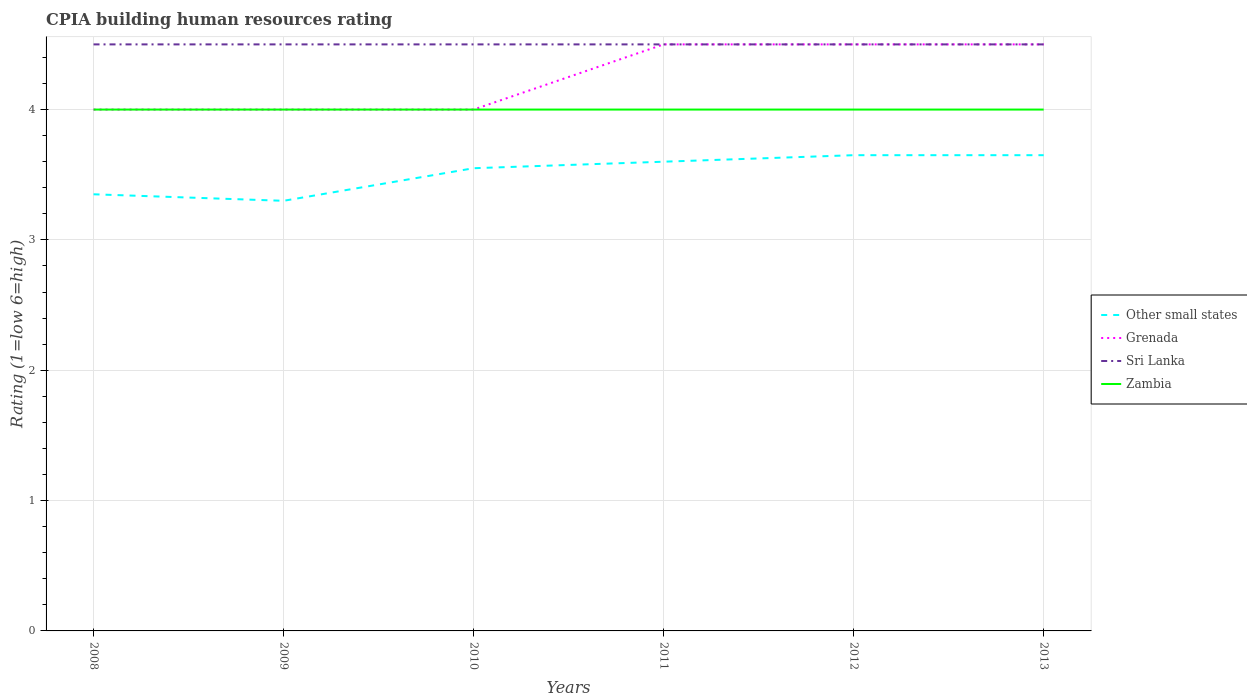Does the line corresponding to Grenada intersect with the line corresponding to Zambia?
Ensure brevity in your answer.  Yes. Across all years, what is the maximum CPIA rating in Zambia?
Give a very brief answer. 4. In which year was the CPIA rating in Sri Lanka maximum?
Your answer should be compact. 2008. What is the total CPIA rating in Zambia in the graph?
Offer a terse response. 0. What is the difference between the highest and the second highest CPIA rating in Grenada?
Keep it short and to the point. 0.5. How many lines are there?
Provide a short and direct response. 4. What is the difference between two consecutive major ticks on the Y-axis?
Provide a succinct answer. 1. Are the values on the major ticks of Y-axis written in scientific E-notation?
Make the answer very short. No. How many legend labels are there?
Provide a short and direct response. 4. What is the title of the graph?
Make the answer very short. CPIA building human resources rating. What is the label or title of the Y-axis?
Your response must be concise. Rating (1=low 6=high). What is the Rating (1=low 6=high) of Other small states in 2008?
Your answer should be compact. 3.35. What is the Rating (1=low 6=high) of Sri Lanka in 2008?
Your response must be concise. 4.5. What is the Rating (1=low 6=high) in Other small states in 2009?
Your answer should be very brief. 3.3. What is the Rating (1=low 6=high) of Sri Lanka in 2009?
Provide a succinct answer. 4.5. What is the Rating (1=low 6=high) of Zambia in 2009?
Provide a short and direct response. 4. What is the Rating (1=low 6=high) in Other small states in 2010?
Provide a succinct answer. 3.55. What is the Rating (1=low 6=high) in Zambia in 2010?
Your response must be concise. 4. What is the Rating (1=low 6=high) of Zambia in 2011?
Your response must be concise. 4. What is the Rating (1=low 6=high) of Other small states in 2012?
Ensure brevity in your answer.  3.65. What is the Rating (1=low 6=high) of Grenada in 2012?
Provide a short and direct response. 4.5. What is the Rating (1=low 6=high) in Sri Lanka in 2012?
Give a very brief answer. 4.5. What is the Rating (1=low 6=high) of Zambia in 2012?
Offer a very short reply. 4. What is the Rating (1=low 6=high) of Other small states in 2013?
Ensure brevity in your answer.  3.65. What is the Rating (1=low 6=high) in Grenada in 2013?
Your answer should be compact. 4.5. What is the Rating (1=low 6=high) in Zambia in 2013?
Give a very brief answer. 4. Across all years, what is the maximum Rating (1=low 6=high) in Other small states?
Offer a terse response. 3.65. Across all years, what is the maximum Rating (1=low 6=high) in Zambia?
Offer a very short reply. 4. Across all years, what is the minimum Rating (1=low 6=high) in Other small states?
Offer a terse response. 3.3. Across all years, what is the minimum Rating (1=low 6=high) of Grenada?
Offer a very short reply. 4. Across all years, what is the minimum Rating (1=low 6=high) in Sri Lanka?
Make the answer very short. 4.5. Across all years, what is the minimum Rating (1=low 6=high) of Zambia?
Keep it short and to the point. 4. What is the total Rating (1=low 6=high) of Other small states in the graph?
Keep it short and to the point. 21.1. What is the total Rating (1=low 6=high) in Grenada in the graph?
Provide a short and direct response. 25.5. What is the total Rating (1=low 6=high) in Sri Lanka in the graph?
Provide a succinct answer. 27. What is the total Rating (1=low 6=high) in Zambia in the graph?
Make the answer very short. 24. What is the difference between the Rating (1=low 6=high) in Other small states in 2008 and that in 2009?
Provide a short and direct response. 0.05. What is the difference between the Rating (1=low 6=high) in Grenada in 2008 and that in 2009?
Offer a very short reply. 0. What is the difference between the Rating (1=low 6=high) of Grenada in 2008 and that in 2010?
Make the answer very short. 0. What is the difference between the Rating (1=low 6=high) of Grenada in 2008 and that in 2011?
Make the answer very short. -0.5. What is the difference between the Rating (1=low 6=high) of Other small states in 2008 and that in 2012?
Your answer should be compact. -0.3. What is the difference between the Rating (1=low 6=high) in Grenada in 2008 and that in 2012?
Offer a terse response. -0.5. What is the difference between the Rating (1=low 6=high) of Sri Lanka in 2008 and that in 2012?
Provide a short and direct response. 0. What is the difference between the Rating (1=low 6=high) in Zambia in 2008 and that in 2013?
Your response must be concise. 0. What is the difference between the Rating (1=low 6=high) in Grenada in 2009 and that in 2010?
Your answer should be very brief. 0. What is the difference between the Rating (1=low 6=high) of Sri Lanka in 2009 and that in 2010?
Ensure brevity in your answer.  0. What is the difference between the Rating (1=low 6=high) in Zambia in 2009 and that in 2010?
Offer a very short reply. 0. What is the difference between the Rating (1=low 6=high) in Sri Lanka in 2009 and that in 2011?
Provide a succinct answer. 0. What is the difference between the Rating (1=low 6=high) of Zambia in 2009 and that in 2011?
Offer a terse response. 0. What is the difference between the Rating (1=low 6=high) of Other small states in 2009 and that in 2012?
Provide a succinct answer. -0.35. What is the difference between the Rating (1=low 6=high) in Sri Lanka in 2009 and that in 2012?
Give a very brief answer. 0. What is the difference between the Rating (1=low 6=high) of Other small states in 2009 and that in 2013?
Give a very brief answer. -0.35. What is the difference between the Rating (1=low 6=high) of Grenada in 2009 and that in 2013?
Your answer should be compact. -0.5. What is the difference between the Rating (1=low 6=high) of Sri Lanka in 2010 and that in 2011?
Keep it short and to the point. 0. What is the difference between the Rating (1=low 6=high) of Zambia in 2010 and that in 2011?
Give a very brief answer. 0. What is the difference between the Rating (1=low 6=high) of Other small states in 2010 and that in 2012?
Ensure brevity in your answer.  -0.1. What is the difference between the Rating (1=low 6=high) in Sri Lanka in 2010 and that in 2012?
Make the answer very short. 0. What is the difference between the Rating (1=low 6=high) in Zambia in 2010 and that in 2012?
Your answer should be very brief. 0. What is the difference between the Rating (1=low 6=high) of Zambia in 2010 and that in 2013?
Keep it short and to the point. 0. What is the difference between the Rating (1=low 6=high) in Other small states in 2011 and that in 2012?
Provide a succinct answer. -0.05. What is the difference between the Rating (1=low 6=high) in Grenada in 2011 and that in 2012?
Your response must be concise. 0. What is the difference between the Rating (1=low 6=high) of Zambia in 2011 and that in 2012?
Offer a very short reply. 0. What is the difference between the Rating (1=low 6=high) in Other small states in 2011 and that in 2013?
Your answer should be compact. -0.05. What is the difference between the Rating (1=low 6=high) in Grenada in 2011 and that in 2013?
Provide a short and direct response. 0. What is the difference between the Rating (1=low 6=high) of Sri Lanka in 2011 and that in 2013?
Ensure brevity in your answer.  0. What is the difference between the Rating (1=low 6=high) of Zambia in 2011 and that in 2013?
Make the answer very short. 0. What is the difference between the Rating (1=low 6=high) of Other small states in 2012 and that in 2013?
Offer a terse response. 0. What is the difference between the Rating (1=low 6=high) of Sri Lanka in 2012 and that in 2013?
Offer a terse response. 0. What is the difference between the Rating (1=low 6=high) of Zambia in 2012 and that in 2013?
Provide a short and direct response. 0. What is the difference between the Rating (1=low 6=high) of Other small states in 2008 and the Rating (1=low 6=high) of Grenada in 2009?
Your response must be concise. -0.65. What is the difference between the Rating (1=low 6=high) of Other small states in 2008 and the Rating (1=low 6=high) of Sri Lanka in 2009?
Keep it short and to the point. -1.15. What is the difference between the Rating (1=low 6=high) in Other small states in 2008 and the Rating (1=low 6=high) in Zambia in 2009?
Keep it short and to the point. -0.65. What is the difference between the Rating (1=low 6=high) of Sri Lanka in 2008 and the Rating (1=low 6=high) of Zambia in 2009?
Your answer should be very brief. 0.5. What is the difference between the Rating (1=low 6=high) in Other small states in 2008 and the Rating (1=low 6=high) in Grenada in 2010?
Your response must be concise. -0.65. What is the difference between the Rating (1=low 6=high) of Other small states in 2008 and the Rating (1=low 6=high) of Sri Lanka in 2010?
Offer a terse response. -1.15. What is the difference between the Rating (1=low 6=high) of Other small states in 2008 and the Rating (1=low 6=high) of Zambia in 2010?
Give a very brief answer. -0.65. What is the difference between the Rating (1=low 6=high) in Grenada in 2008 and the Rating (1=low 6=high) in Sri Lanka in 2010?
Give a very brief answer. -0.5. What is the difference between the Rating (1=low 6=high) of Grenada in 2008 and the Rating (1=low 6=high) of Zambia in 2010?
Your answer should be very brief. 0. What is the difference between the Rating (1=low 6=high) in Other small states in 2008 and the Rating (1=low 6=high) in Grenada in 2011?
Your answer should be very brief. -1.15. What is the difference between the Rating (1=low 6=high) in Other small states in 2008 and the Rating (1=low 6=high) in Sri Lanka in 2011?
Your answer should be very brief. -1.15. What is the difference between the Rating (1=low 6=high) of Other small states in 2008 and the Rating (1=low 6=high) of Zambia in 2011?
Your answer should be compact. -0.65. What is the difference between the Rating (1=low 6=high) in Other small states in 2008 and the Rating (1=low 6=high) in Grenada in 2012?
Provide a short and direct response. -1.15. What is the difference between the Rating (1=low 6=high) of Other small states in 2008 and the Rating (1=low 6=high) of Sri Lanka in 2012?
Make the answer very short. -1.15. What is the difference between the Rating (1=low 6=high) in Other small states in 2008 and the Rating (1=low 6=high) in Zambia in 2012?
Your response must be concise. -0.65. What is the difference between the Rating (1=low 6=high) in Sri Lanka in 2008 and the Rating (1=low 6=high) in Zambia in 2012?
Offer a very short reply. 0.5. What is the difference between the Rating (1=low 6=high) of Other small states in 2008 and the Rating (1=low 6=high) of Grenada in 2013?
Your answer should be very brief. -1.15. What is the difference between the Rating (1=low 6=high) in Other small states in 2008 and the Rating (1=low 6=high) in Sri Lanka in 2013?
Keep it short and to the point. -1.15. What is the difference between the Rating (1=low 6=high) in Other small states in 2008 and the Rating (1=low 6=high) in Zambia in 2013?
Provide a succinct answer. -0.65. What is the difference between the Rating (1=low 6=high) in Sri Lanka in 2008 and the Rating (1=low 6=high) in Zambia in 2013?
Keep it short and to the point. 0.5. What is the difference between the Rating (1=low 6=high) in Other small states in 2009 and the Rating (1=low 6=high) in Grenada in 2010?
Ensure brevity in your answer.  -0.7. What is the difference between the Rating (1=low 6=high) of Other small states in 2009 and the Rating (1=low 6=high) of Sri Lanka in 2010?
Your response must be concise. -1.2. What is the difference between the Rating (1=low 6=high) in Grenada in 2009 and the Rating (1=low 6=high) in Sri Lanka in 2010?
Keep it short and to the point. -0.5. What is the difference between the Rating (1=low 6=high) in Grenada in 2009 and the Rating (1=low 6=high) in Zambia in 2010?
Offer a terse response. 0. What is the difference between the Rating (1=low 6=high) in Other small states in 2009 and the Rating (1=low 6=high) in Grenada in 2011?
Provide a short and direct response. -1.2. What is the difference between the Rating (1=low 6=high) of Other small states in 2009 and the Rating (1=low 6=high) of Sri Lanka in 2011?
Keep it short and to the point. -1.2. What is the difference between the Rating (1=low 6=high) in Sri Lanka in 2009 and the Rating (1=low 6=high) in Zambia in 2011?
Ensure brevity in your answer.  0.5. What is the difference between the Rating (1=low 6=high) of Other small states in 2009 and the Rating (1=low 6=high) of Grenada in 2013?
Your response must be concise. -1.2. What is the difference between the Rating (1=low 6=high) in Other small states in 2009 and the Rating (1=low 6=high) in Sri Lanka in 2013?
Provide a succinct answer. -1.2. What is the difference between the Rating (1=low 6=high) in Other small states in 2009 and the Rating (1=low 6=high) in Zambia in 2013?
Give a very brief answer. -0.7. What is the difference between the Rating (1=low 6=high) in Sri Lanka in 2009 and the Rating (1=low 6=high) in Zambia in 2013?
Ensure brevity in your answer.  0.5. What is the difference between the Rating (1=low 6=high) in Other small states in 2010 and the Rating (1=low 6=high) in Grenada in 2011?
Your answer should be compact. -0.95. What is the difference between the Rating (1=low 6=high) in Other small states in 2010 and the Rating (1=low 6=high) in Sri Lanka in 2011?
Provide a short and direct response. -0.95. What is the difference between the Rating (1=low 6=high) of Other small states in 2010 and the Rating (1=low 6=high) of Zambia in 2011?
Keep it short and to the point. -0.45. What is the difference between the Rating (1=low 6=high) of Grenada in 2010 and the Rating (1=low 6=high) of Sri Lanka in 2011?
Your answer should be very brief. -0.5. What is the difference between the Rating (1=low 6=high) of Grenada in 2010 and the Rating (1=low 6=high) of Zambia in 2011?
Keep it short and to the point. 0. What is the difference between the Rating (1=low 6=high) of Sri Lanka in 2010 and the Rating (1=low 6=high) of Zambia in 2011?
Make the answer very short. 0.5. What is the difference between the Rating (1=low 6=high) of Other small states in 2010 and the Rating (1=low 6=high) of Grenada in 2012?
Make the answer very short. -0.95. What is the difference between the Rating (1=low 6=high) in Other small states in 2010 and the Rating (1=low 6=high) in Sri Lanka in 2012?
Provide a short and direct response. -0.95. What is the difference between the Rating (1=low 6=high) in Other small states in 2010 and the Rating (1=low 6=high) in Zambia in 2012?
Your answer should be very brief. -0.45. What is the difference between the Rating (1=low 6=high) of Grenada in 2010 and the Rating (1=low 6=high) of Zambia in 2012?
Offer a terse response. 0. What is the difference between the Rating (1=low 6=high) of Sri Lanka in 2010 and the Rating (1=low 6=high) of Zambia in 2012?
Provide a succinct answer. 0.5. What is the difference between the Rating (1=low 6=high) of Other small states in 2010 and the Rating (1=low 6=high) of Grenada in 2013?
Make the answer very short. -0.95. What is the difference between the Rating (1=low 6=high) in Other small states in 2010 and the Rating (1=low 6=high) in Sri Lanka in 2013?
Offer a very short reply. -0.95. What is the difference between the Rating (1=low 6=high) in Other small states in 2010 and the Rating (1=low 6=high) in Zambia in 2013?
Your response must be concise. -0.45. What is the difference between the Rating (1=low 6=high) in Grenada in 2010 and the Rating (1=low 6=high) in Zambia in 2013?
Make the answer very short. 0. What is the difference between the Rating (1=low 6=high) in Other small states in 2011 and the Rating (1=low 6=high) in Zambia in 2012?
Keep it short and to the point. -0.4. What is the difference between the Rating (1=low 6=high) in Grenada in 2011 and the Rating (1=low 6=high) in Sri Lanka in 2012?
Offer a terse response. 0. What is the difference between the Rating (1=low 6=high) of Sri Lanka in 2011 and the Rating (1=low 6=high) of Zambia in 2012?
Keep it short and to the point. 0.5. What is the difference between the Rating (1=low 6=high) in Other small states in 2011 and the Rating (1=low 6=high) in Zambia in 2013?
Offer a very short reply. -0.4. What is the difference between the Rating (1=low 6=high) in Grenada in 2011 and the Rating (1=low 6=high) in Zambia in 2013?
Provide a succinct answer. 0.5. What is the difference between the Rating (1=low 6=high) of Other small states in 2012 and the Rating (1=low 6=high) of Grenada in 2013?
Provide a succinct answer. -0.85. What is the difference between the Rating (1=low 6=high) in Other small states in 2012 and the Rating (1=low 6=high) in Sri Lanka in 2013?
Give a very brief answer. -0.85. What is the difference between the Rating (1=low 6=high) of Other small states in 2012 and the Rating (1=low 6=high) of Zambia in 2013?
Give a very brief answer. -0.35. What is the average Rating (1=low 6=high) in Other small states per year?
Offer a terse response. 3.52. What is the average Rating (1=low 6=high) in Grenada per year?
Your answer should be compact. 4.25. What is the average Rating (1=low 6=high) in Sri Lanka per year?
Make the answer very short. 4.5. What is the average Rating (1=low 6=high) of Zambia per year?
Your answer should be compact. 4. In the year 2008, what is the difference between the Rating (1=low 6=high) in Other small states and Rating (1=low 6=high) in Grenada?
Offer a terse response. -0.65. In the year 2008, what is the difference between the Rating (1=low 6=high) of Other small states and Rating (1=low 6=high) of Sri Lanka?
Your answer should be compact. -1.15. In the year 2008, what is the difference between the Rating (1=low 6=high) of Other small states and Rating (1=low 6=high) of Zambia?
Keep it short and to the point. -0.65. In the year 2008, what is the difference between the Rating (1=low 6=high) of Grenada and Rating (1=low 6=high) of Sri Lanka?
Your response must be concise. -0.5. In the year 2008, what is the difference between the Rating (1=low 6=high) of Grenada and Rating (1=low 6=high) of Zambia?
Make the answer very short. 0. In the year 2008, what is the difference between the Rating (1=low 6=high) of Sri Lanka and Rating (1=low 6=high) of Zambia?
Provide a short and direct response. 0.5. In the year 2009, what is the difference between the Rating (1=low 6=high) in Other small states and Rating (1=low 6=high) in Grenada?
Provide a short and direct response. -0.7. In the year 2009, what is the difference between the Rating (1=low 6=high) of Other small states and Rating (1=low 6=high) of Zambia?
Your answer should be compact. -0.7. In the year 2010, what is the difference between the Rating (1=low 6=high) in Other small states and Rating (1=low 6=high) in Grenada?
Your answer should be very brief. -0.45. In the year 2010, what is the difference between the Rating (1=low 6=high) of Other small states and Rating (1=low 6=high) of Sri Lanka?
Offer a terse response. -0.95. In the year 2010, what is the difference between the Rating (1=low 6=high) of Other small states and Rating (1=low 6=high) of Zambia?
Your answer should be very brief. -0.45. In the year 2010, what is the difference between the Rating (1=low 6=high) in Sri Lanka and Rating (1=low 6=high) in Zambia?
Give a very brief answer. 0.5. In the year 2011, what is the difference between the Rating (1=low 6=high) of Other small states and Rating (1=low 6=high) of Grenada?
Ensure brevity in your answer.  -0.9. In the year 2011, what is the difference between the Rating (1=low 6=high) in Other small states and Rating (1=low 6=high) in Sri Lanka?
Provide a succinct answer. -0.9. In the year 2011, what is the difference between the Rating (1=low 6=high) of Grenada and Rating (1=low 6=high) of Sri Lanka?
Your answer should be compact. 0. In the year 2011, what is the difference between the Rating (1=low 6=high) in Grenada and Rating (1=low 6=high) in Zambia?
Your answer should be compact. 0.5. In the year 2011, what is the difference between the Rating (1=low 6=high) of Sri Lanka and Rating (1=low 6=high) of Zambia?
Offer a very short reply. 0.5. In the year 2012, what is the difference between the Rating (1=low 6=high) in Other small states and Rating (1=low 6=high) in Grenada?
Provide a succinct answer. -0.85. In the year 2012, what is the difference between the Rating (1=low 6=high) of Other small states and Rating (1=low 6=high) of Sri Lanka?
Give a very brief answer. -0.85. In the year 2012, what is the difference between the Rating (1=low 6=high) of Other small states and Rating (1=low 6=high) of Zambia?
Keep it short and to the point. -0.35. In the year 2012, what is the difference between the Rating (1=low 6=high) of Grenada and Rating (1=low 6=high) of Sri Lanka?
Provide a short and direct response. 0. In the year 2012, what is the difference between the Rating (1=low 6=high) of Sri Lanka and Rating (1=low 6=high) of Zambia?
Give a very brief answer. 0.5. In the year 2013, what is the difference between the Rating (1=low 6=high) in Other small states and Rating (1=low 6=high) in Grenada?
Make the answer very short. -0.85. In the year 2013, what is the difference between the Rating (1=low 6=high) in Other small states and Rating (1=low 6=high) in Sri Lanka?
Your response must be concise. -0.85. In the year 2013, what is the difference between the Rating (1=low 6=high) in Other small states and Rating (1=low 6=high) in Zambia?
Offer a very short reply. -0.35. In the year 2013, what is the difference between the Rating (1=low 6=high) in Grenada and Rating (1=low 6=high) in Sri Lanka?
Provide a short and direct response. 0. What is the ratio of the Rating (1=low 6=high) of Other small states in 2008 to that in 2009?
Provide a succinct answer. 1.02. What is the ratio of the Rating (1=low 6=high) in Other small states in 2008 to that in 2010?
Give a very brief answer. 0.94. What is the ratio of the Rating (1=low 6=high) in Grenada in 2008 to that in 2010?
Your answer should be compact. 1. What is the ratio of the Rating (1=low 6=high) in Zambia in 2008 to that in 2010?
Offer a terse response. 1. What is the ratio of the Rating (1=low 6=high) in Other small states in 2008 to that in 2011?
Your response must be concise. 0.93. What is the ratio of the Rating (1=low 6=high) in Other small states in 2008 to that in 2012?
Give a very brief answer. 0.92. What is the ratio of the Rating (1=low 6=high) of Grenada in 2008 to that in 2012?
Offer a very short reply. 0.89. What is the ratio of the Rating (1=low 6=high) of Sri Lanka in 2008 to that in 2012?
Give a very brief answer. 1. What is the ratio of the Rating (1=low 6=high) in Zambia in 2008 to that in 2012?
Your response must be concise. 1. What is the ratio of the Rating (1=low 6=high) of Other small states in 2008 to that in 2013?
Make the answer very short. 0.92. What is the ratio of the Rating (1=low 6=high) of Sri Lanka in 2008 to that in 2013?
Give a very brief answer. 1. What is the ratio of the Rating (1=low 6=high) in Zambia in 2008 to that in 2013?
Offer a terse response. 1. What is the ratio of the Rating (1=low 6=high) in Other small states in 2009 to that in 2010?
Offer a very short reply. 0.93. What is the ratio of the Rating (1=low 6=high) in Grenada in 2009 to that in 2010?
Your answer should be compact. 1. What is the ratio of the Rating (1=low 6=high) in Zambia in 2009 to that in 2010?
Make the answer very short. 1. What is the ratio of the Rating (1=low 6=high) in Other small states in 2009 to that in 2011?
Give a very brief answer. 0.92. What is the ratio of the Rating (1=low 6=high) in Sri Lanka in 2009 to that in 2011?
Give a very brief answer. 1. What is the ratio of the Rating (1=low 6=high) in Other small states in 2009 to that in 2012?
Make the answer very short. 0.9. What is the ratio of the Rating (1=low 6=high) in Sri Lanka in 2009 to that in 2012?
Keep it short and to the point. 1. What is the ratio of the Rating (1=low 6=high) in Other small states in 2009 to that in 2013?
Make the answer very short. 0.9. What is the ratio of the Rating (1=low 6=high) of Grenada in 2009 to that in 2013?
Give a very brief answer. 0.89. What is the ratio of the Rating (1=low 6=high) in Sri Lanka in 2009 to that in 2013?
Offer a terse response. 1. What is the ratio of the Rating (1=low 6=high) of Zambia in 2009 to that in 2013?
Make the answer very short. 1. What is the ratio of the Rating (1=low 6=high) of Other small states in 2010 to that in 2011?
Give a very brief answer. 0.99. What is the ratio of the Rating (1=low 6=high) in Sri Lanka in 2010 to that in 2011?
Ensure brevity in your answer.  1. What is the ratio of the Rating (1=low 6=high) in Zambia in 2010 to that in 2011?
Provide a short and direct response. 1. What is the ratio of the Rating (1=low 6=high) of Other small states in 2010 to that in 2012?
Ensure brevity in your answer.  0.97. What is the ratio of the Rating (1=low 6=high) of Zambia in 2010 to that in 2012?
Give a very brief answer. 1. What is the ratio of the Rating (1=low 6=high) of Other small states in 2010 to that in 2013?
Your response must be concise. 0.97. What is the ratio of the Rating (1=low 6=high) in Grenada in 2010 to that in 2013?
Offer a terse response. 0.89. What is the ratio of the Rating (1=low 6=high) in Sri Lanka in 2010 to that in 2013?
Give a very brief answer. 1. What is the ratio of the Rating (1=low 6=high) in Zambia in 2010 to that in 2013?
Your response must be concise. 1. What is the ratio of the Rating (1=low 6=high) in Other small states in 2011 to that in 2012?
Make the answer very short. 0.99. What is the ratio of the Rating (1=low 6=high) in Other small states in 2011 to that in 2013?
Keep it short and to the point. 0.99. What is the ratio of the Rating (1=low 6=high) in Grenada in 2012 to that in 2013?
Provide a succinct answer. 1. What is the ratio of the Rating (1=low 6=high) in Sri Lanka in 2012 to that in 2013?
Keep it short and to the point. 1. What is the ratio of the Rating (1=low 6=high) in Zambia in 2012 to that in 2013?
Your answer should be very brief. 1. What is the difference between the highest and the second highest Rating (1=low 6=high) of Zambia?
Provide a succinct answer. 0. What is the difference between the highest and the lowest Rating (1=low 6=high) of Sri Lanka?
Offer a terse response. 0. What is the difference between the highest and the lowest Rating (1=low 6=high) in Zambia?
Offer a terse response. 0. 